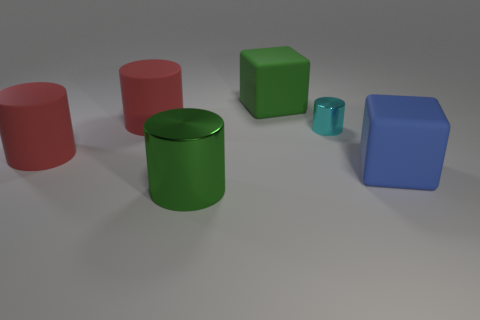Subtract 1 cylinders. How many cylinders are left? 3 Add 2 large objects. How many objects exist? 8 Subtract all cylinders. How many objects are left? 2 Add 3 green metal objects. How many green metal objects exist? 4 Subtract 1 green cubes. How many objects are left? 5 Subtract all green matte things. Subtract all large brown matte cubes. How many objects are left? 5 Add 4 large green shiny cylinders. How many large green shiny cylinders are left? 5 